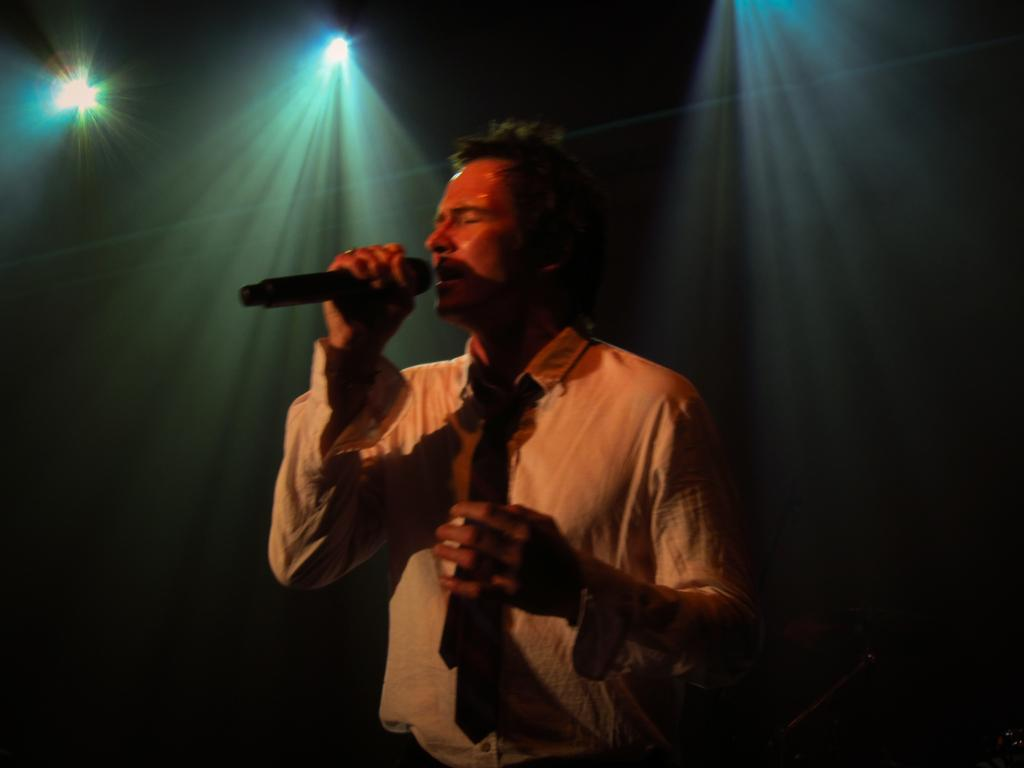What is the man in the image doing? The man is singing in the image. What is the man holding while singing? The man is holding a microphone. Can you describe the man's attire? The man is wearing a tie. What can be seen in the background of the image? There are lights visible in the image. What type of smell can be detected from the man's elbow in the image? There is no mention of smell or the man's elbow in the image, so it cannot be determined. 